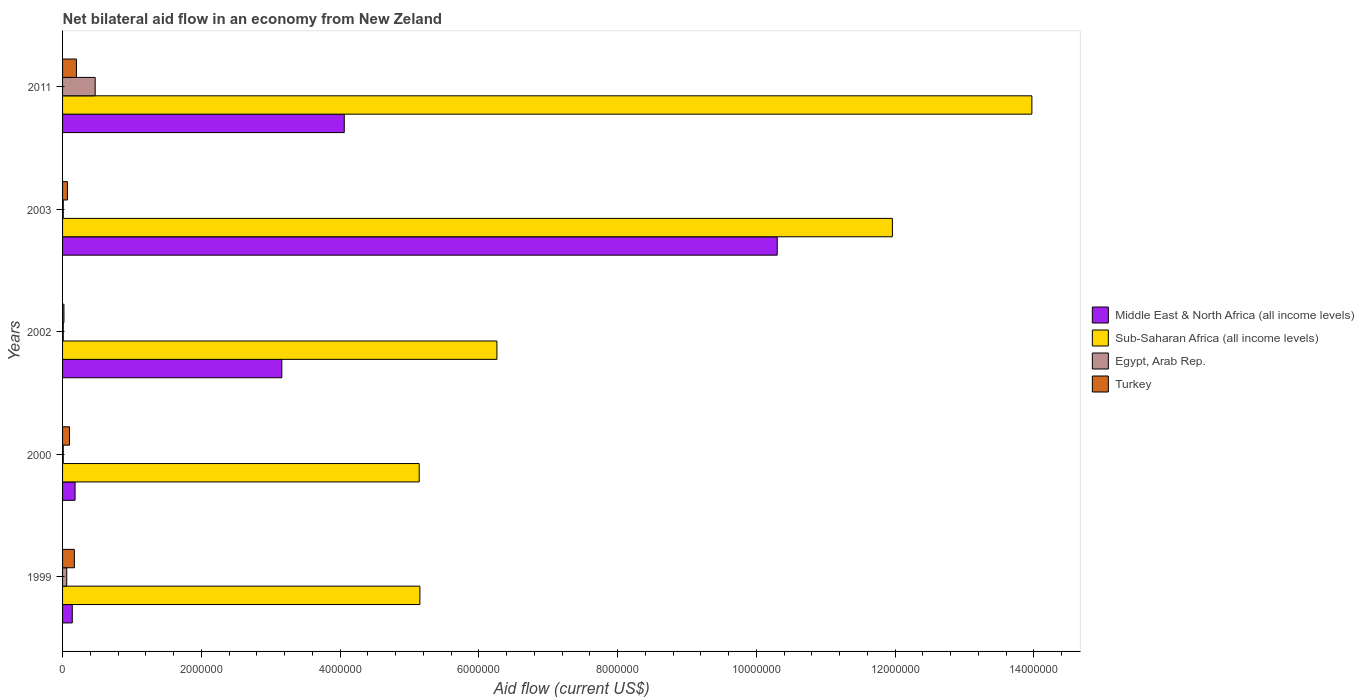How many different coloured bars are there?
Provide a succinct answer. 4. Are the number of bars per tick equal to the number of legend labels?
Your response must be concise. Yes. Are the number of bars on each tick of the Y-axis equal?
Your answer should be compact. Yes. How many bars are there on the 1st tick from the bottom?
Your answer should be very brief. 4. In how many cases, is the number of bars for a given year not equal to the number of legend labels?
Provide a short and direct response. 0. What is the net bilateral aid flow in Turkey in 1999?
Your answer should be very brief. 1.70e+05. Across all years, what is the minimum net bilateral aid flow in Middle East & North Africa (all income levels)?
Offer a very short reply. 1.40e+05. In which year was the net bilateral aid flow in Middle East & North Africa (all income levels) maximum?
Ensure brevity in your answer.  2003. In which year was the net bilateral aid flow in Sub-Saharan Africa (all income levels) minimum?
Provide a short and direct response. 2000. What is the total net bilateral aid flow in Sub-Saharan Africa (all income levels) in the graph?
Make the answer very short. 4.25e+07. What is the difference between the net bilateral aid flow in Sub-Saharan Africa (all income levels) in 1999 and that in 2003?
Make the answer very short. -6.81e+06. What is the average net bilateral aid flow in Sub-Saharan Africa (all income levels) per year?
Offer a very short reply. 8.50e+06. In the year 2003, what is the difference between the net bilateral aid flow in Middle East & North Africa (all income levels) and net bilateral aid flow in Turkey?
Give a very brief answer. 1.02e+07. In how many years, is the net bilateral aid flow in Sub-Saharan Africa (all income levels) greater than 7200000 US$?
Offer a very short reply. 2. Is the difference between the net bilateral aid flow in Middle East & North Africa (all income levels) in 2000 and 2003 greater than the difference between the net bilateral aid flow in Turkey in 2000 and 2003?
Keep it short and to the point. No. What is the difference between the highest and the second highest net bilateral aid flow in Sub-Saharan Africa (all income levels)?
Your answer should be compact. 2.01e+06. What is the difference between the highest and the lowest net bilateral aid flow in Turkey?
Make the answer very short. 1.80e+05. In how many years, is the net bilateral aid flow in Sub-Saharan Africa (all income levels) greater than the average net bilateral aid flow in Sub-Saharan Africa (all income levels) taken over all years?
Keep it short and to the point. 2. Is the sum of the net bilateral aid flow in Middle East & North Africa (all income levels) in 2000 and 2003 greater than the maximum net bilateral aid flow in Egypt, Arab Rep. across all years?
Give a very brief answer. Yes. What does the 4th bar from the top in 2003 represents?
Offer a terse response. Middle East & North Africa (all income levels). Is it the case that in every year, the sum of the net bilateral aid flow in Egypt, Arab Rep. and net bilateral aid flow in Turkey is greater than the net bilateral aid flow in Middle East & North Africa (all income levels)?
Your response must be concise. No. Does the graph contain any zero values?
Give a very brief answer. No. Does the graph contain grids?
Your response must be concise. No. How are the legend labels stacked?
Offer a very short reply. Vertical. What is the title of the graph?
Provide a succinct answer. Net bilateral aid flow in an economy from New Zeland. Does "Benin" appear as one of the legend labels in the graph?
Your response must be concise. No. What is the Aid flow (current US$) of Middle East & North Africa (all income levels) in 1999?
Provide a succinct answer. 1.40e+05. What is the Aid flow (current US$) in Sub-Saharan Africa (all income levels) in 1999?
Ensure brevity in your answer.  5.15e+06. What is the Aid flow (current US$) of Egypt, Arab Rep. in 1999?
Keep it short and to the point. 6.00e+04. What is the Aid flow (current US$) in Sub-Saharan Africa (all income levels) in 2000?
Keep it short and to the point. 5.14e+06. What is the Aid flow (current US$) of Turkey in 2000?
Your response must be concise. 1.00e+05. What is the Aid flow (current US$) of Middle East & North Africa (all income levels) in 2002?
Offer a very short reply. 3.16e+06. What is the Aid flow (current US$) of Sub-Saharan Africa (all income levels) in 2002?
Offer a terse response. 6.26e+06. What is the Aid flow (current US$) in Egypt, Arab Rep. in 2002?
Your answer should be very brief. 10000. What is the Aid flow (current US$) of Middle East & North Africa (all income levels) in 2003?
Your answer should be very brief. 1.03e+07. What is the Aid flow (current US$) of Sub-Saharan Africa (all income levels) in 2003?
Offer a terse response. 1.20e+07. What is the Aid flow (current US$) of Middle East & North Africa (all income levels) in 2011?
Provide a succinct answer. 4.06e+06. What is the Aid flow (current US$) in Sub-Saharan Africa (all income levels) in 2011?
Provide a succinct answer. 1.40e+07. What is the Aid flow (current US$) in Egypt, Arab Rep. in 2011?
Make the answer very short. 4.70e+05. What is the Aid flow (current US$) in Turkey in 2011?
Your response must be concise. 2.00e+05. Across all years, what is the maximum Aid flow (current US$) of Middle East & North Africa (all income levels)?
Ensure brevity in your answer.  1.03e+07. Across all years, what is the maximum Aid flow (current US$) of Sub-Saharan Africa (all income levels)?
Your answer should be very brief. 1.40e+07. Across all years, what is the minimum Aid flow (current US$) of Sub-Saharan Africa (all income levels)?
Offer a very short reply. 5.14e+06. Across all years, what is the minimum Aid flow (current US$) in Egypt, Arab Rep.?
Ensure brevity in your answer.  10000. Across all years, what is the minimum Aid flow (current US$) in Turkey?
Provide a succinct answer. 2.00e+04. What is the total Aid flow (current US$) of Middle East & North Africa (all income levels) in the graph?
Offer a terse response. 1.78e+07. What is the total Aid flow (current US$) in Sub-Saharan Africa (all income levels) in the graph?
Give a very brief answer. 4.25e+07. What is the total Aid flow (current US$) in Egypt, Arab Rep. in the graph?
Provide a short and direct response. 5.60e+05. What is the total Aid flow (current US$) in Turkey in the graph?
Offer a terse response. 5.60e+05. What is the difference between the Aid flow (current US$) in Sub-Saharan Africa (all income levels) in 1999 and that in 2000?
Give a very brief answer. 10000. What is the difference between the Aid flow (current US$) of Egypt, Arab Rep. in 1999 and that in 2000?
Give a very brief answer. 5.00e+04. What is the difference between the Aid flow (current US$) of Turkey in 1999 and that in 2000?
Ensure brevity in your answer.  7.00e+04. What is the difference between the Aid flow (current US$) in Middle East & North Africa (all income levels) in 1999 and that in 2002?
Provide a short and direct response. -3.02e+06. What is the difference between the Aid flow (current US$) in Sub-Saharan Africa (all income levels) in 1999 and that in 2002?
Your answer should be very brief. -1.11e+06. What is the difference between the Aid flow (current US$) of Egypt, Arab Rep. in 1999 and that in 2002?
Give a very brief answer. 5.00e+04. What is the difference between the Aid flow (current US$) in Middle East & North Africa (all income levels) in 1999 and that in 2003?
Your answer should be very brief. -1.02e+07. What is the difference between the Aid flow (current US$) of Sub-Saharan Africa (all income levels) in 1999 and that in 2003?
Provide a short and direct response. -6.81e+06. What is the difference between the Aid flow (current US$) of Egypt, Arab Rep. in 1999 and that in 2003?
Provide a short and direct response. 5.00e+04. What is the difference between the Aid flow (current US$) of Middle East & North Africa (all income levels) in 1999 and that in 2011?
Provide a succinct answer. -3.92e+06. What is the difference between the Aid flow (current US$) in Sub-Saharan Africa (all income levels) in 1999 and that in 2011?
Your answer should be very brief. -8.82e+06. What is the difference between the Aid flow (current US$) of Egypt, Arab Rep. in 1999 and that in 2011?
Provide a short and direct response. -4.10e+05. What is the difference between the Aid flow (current US$) in Turkey in 1999 and that in 2011?
Keep it short and to the point. -3.00e+04. What is the difference between the Aid flow (current US$) of Middle East & North Africa (all income levels) in 2000 and that in 2002?
Make the answer very short. -2.98e+06. What is the difference between the Aid flow (current US$) in Sub-Saharan Africa (all income levels) in 2000 and that in 2002?
Your answer should be very brief. -1.12e+06. What is the difference between the Aid flow (current US$) of Turkey in 2000 and that in 2002?
Offer a terse response. 8.00e+04. What is the difference between the Aid flow (current US$) of Middle East & North Africa (all income levels) in 2000 and that in 2003?
Your response must be concise. -1.01e+07. What is the difference between the Aid flow (current US$) in Sub-Saharan Africa (all income levels) in 2000 and that in 2003?
Your answer should be compact. -6.82e+06. What is the difference between the Aid flow (current US$) in Egypt, Arab Rep. in 2000 and that in 2003?
Give a very brief answer. 0. What is the difference between the Aid flow (current US$) of Turkey in 2000 and that in 2003?
Your response must be concise. 3.00e+04. What is the difference between the Aid flow (current US$) in Middle East & North Africa (all income levels) in 2000 and that in 2011?
Give a very brief answer. -3.88e+06. What is the difference between the Aid flow (current US$) of Sub-Saharan Africa (all income levels) in 2000 and that in 2011?
Provide a succinct answer. -8.83e+06. What is the difference between the Aid flow (current US$) of Egypt, Arab Rep. in 2000 and that in 2011?
Provide a short and direct response. -4.60e+05. What is the difference between the Aid flow (current US$) in Middle East & North Africa (all income levels) in 2002 and that in 2003?
Your answer should be compact. -7.14e+06. What is the difference between the Aid flow (current US$) in Sub-Saharan Africa (all income levels) in 2002 and that in 2003?
Offer a very short reply. -5.70e+06. What is the difference between the Aid flow (current US$) in Egypt, Arab Rep. in 2002 and that in 2003?
Your answer should be very brief. 0. What is the difference between the Aid flow (current US$) in Middle East & North Africa (all income levels) in 2002 and that in 2011?
Give a very brief answer. -9.00e+05. What is the difference between the Aid flow (current US$) in Sub-Saharan Africa (all income levels) in 2002 and that in 2011?
Ensure brevity in your answer.  -7.71e+06. What is the difference between the Aid flow (current US$) in Egypt, Arab Rep. in 2002 and that in 2011?
Ensure brevity in your answer.  -4.60e+05. What is the difference between the Aid flow (current US$) of Turkey in 2002 and that in 2011?
Offer a terse response. -1.80e+05. What is the difference between the Aid flow (current US$) in Middle East & North Africa (all income levels) in 2003 and that in 2011?
Make the answer very short. 6.24e+06. What is the difference between the Aid flow (current US$) of Sub-Saharan Africa (all income levels) in 2003 and that in 2011?
Offer a terse response. -2.01e+06. What is the difference between the Aid flow (current US$) of Egypt, Arab Rep. in 2003 and that in 2011?
Your answer should be compact. -4.60e+05. What is the difference between the Aid flow (current US$) in Turkey in 2003 and that in 2011?
Your response must be concise. -1.30e+05. What is the difference between the Aid flow (current US$) in Middle East & North Africa (all income levels) in 1999 and the Aid flow (current US$) in Sub-Saharan Africa (all income levels) in 2000?
Provide a succinct answer. -5.00e+06. What is the difference between the Aid flow (current US$) of Middle East & North Africa (all income levels) in 1999 and the Aid flow (current US$) of Turkey in 2000?
Your answer should be very brief. 4.00e+04. What is the difference between the Aid flow (current US$) of Sub-Saharan Africa (all income levels) in 1999 and the Aid flow (current US$) of Egypt, Arab Rep. in 2000?
Provide a short and direct response. 5.14e+06. What is the difference between the Aid flow (current US$) of Sub-Saharan Africa (all income levels) in 1999 and the Aid flow (current US$) of Turkey in 2000?
Provide a succinct answer. 5.05e+06. What is the difference between the Aid flow (current US$) in Egypt, Arab Rep. in 1999 and the Aid flow (current US$) in Turkey in 2000?
Provide a succinct answer. -4.00e+04. What is the difference between the Aid flow (current US$) in Middle East & North Africa (all income levels) in 1999 and the Aid flow (current US$) in Sub-Saharan Africa (all income levels) in 2002?
Provide a short and direct response. -6.12e+06. What is the difference between the Aid flow (current US$) in Middle East & North Africa (all income levels) in 1999 and the Aid flow (current US$) in Egypt, Arab Rep. in 2002?
Ensure brevity in your answer.  1.30e+05. What is the difference between the Aid flow (current US$) in Sub-Saharan Africa (all income levels) in 1999 and the Aid flow (current US$) in Egypt, Arab Rep. in 2002?
Give a very brief answer. 5.14e+06. What is the difference between the Aid flow (current US$) of Sub-Saharan Africa (all income levels) in 1999 and the Aid flow (current US$) of Turkey in 2002?
Give a very brief answer. 5.13e+06. What is the difference between the Aid flow (current US$) of Egypt, Arab Rep. in 1999 and the Aid flow (current US$) of Turkey in 2002?
Offer a terse response. 4.00e+04. What is the difference between the Aid flow (current US$) of Middle East & North Africa (all income levels) in 1999 and the Aid flow (current US$) of Sub-Saharan Africa (all income levels) in 2003?
Provide a short and direct response. -1.18e+07. What is the difference between the Aid flow (current US$) in Middle East & North Africa (all income levels) in 1999 and the Aid flow (current US$) in Egypt, Arab Rep. in 2003?
Provide a short and direct response. 1.30e+05. What is the difference between the Aid flow (current US$) of Sub-Saharan Africa (all income levels) in 1999 and the Aid flow (current US$) of Egypt, Arab Rep. in 2003?
Ensure brevity in your answer.  5.14e+06. What is the difference between the Aid flow (current US$) in Sub-Saharan Africa (all income levels) in 1999 and the Aid flow (current US$) in Turkey in 2003?
Offer a very short reply. 5.08e+06. What is the difference between the Aid flow (current US$) of Middle East & North Africa (all income levels) in 1999 and the Aid flow (current US$) of Sub-Saharan Africa (all income levels) in 2011?
Ensure brevity in your answer.  -1.38e+07. What is the difference between the Aid flow (current US$) of Middle East & North Africa (all income levels) in 1999 and the Aid flow (current US$) of Egypt, Arab Rep. in 2011?
Offer a terse response. -3.30e+05. What is the difference between the Aid flow (current US$) of Middle East & North Africa (all income levels) in 1999 and the Aid flow (current US$) of Turkey in 2011?
Offer a very short reply. -6.00e+04. What is the difference between the Aid flow (current US$) of Sub-Saharan Africa (all income levels) in 1999 and the Aid flow (current US$) of Egypt, Arab Rep. in 2011?
Provide a short and direct response. 4.68e+06. What is the difference between the Aid flow (current US$) in Sub-Saharan Africa (all income levels) in 1999 and the Aid flow (current US$) in Turkey in 2011?
Provide a short and direct response. 4.95e+06. What is the difference between the Aid flow (current US$) in Egypt, Arab Rep. in 1999 and the Aid flow (current US$) in Turkey in 2011?
Your answer should be compact. -1.40e+05. What is the difference between the Aid flow (current US$) in Middle East & North Africa (all income levels) in 2000 and the Aid flow (current US$) in Sub-Saharan Africa (all income levels) in 2002?
Provide a succinct answer. -6.08e+06. What is the difference between the Aid flow (current US$) in Middle East & North Africa (all income levels) in 2000 and the Aid flow (current US$) in Egypt, Arab Rep. in 2002?
Ensure brevity in your answer.  1.70e+05. What is the difference between the Aid flow (current US$) of Middle East & North Africa (all income levels) in 2000 and the Aid flow (current US$) of Turkey in 2002?
Your response must be concise. 1.60e+05. What is the difference between the Aid flow (current US$) of Sub-Saharan Africa (all income levels) in 2000 and the Aid flow (current US$) of Egypt, Arab Rep. in 2002?
Provide a succinct answer. 5.13e+06. What is the difference between the Aid flow (current US$) in Sub-Saharan Africa (all income levels) in 2000 and the Aid flow (current US$) in Turkey in 2002?
Offer a terse response. 5.12e+06. What is the difference between the Aid flow (current US$) of Middle East & North Africa (all income levels) in 2000 and the Aid flow (current US$) of Sub-Saharan Africa (all income levels) in 2003?
Your answer should be very brief. -1.18e+07. What is the difference between the Aid flow (current US$) of Sub-Saharan Africa (all income levels) in 2000 and the Aid flow (current US$) of Egypt, Arab Rep. in 2003?
Offer a very short reply. 5.13e+06. What is the difference between the Aid flow (current US$) in Sub-Saharan Africa (all income levels) in 2000 and the Aid flow (current US$) in Turkey in 2003?
Make the answer very short. 5.07e+06. What is the difference between the Aid flow (current US$) in Egypt, Arab Rep. in 2000 and the Aid flow (current US$) in Turkey in 2003?
Your response must be concise. -6.00e+04. What is the difference between the Aid flow (current US$) of Middle East & North Africa (all income levels) in 2000 and the Aid flow (current US$) of Sub-Saharan Africa (all income levels) in 2011?
Provide a succinct answer. -1.38e+07. What is the difference between the Aid flow (current US$) of Middle East & North Africa (all income levels) in 2000 and the Aid flow (current US$) of Turkey in 2011?
Give a very brief answer. -2.00e+04. What is the difference between the Aid flow (current US$) of Sub-Saharan Africa (all income levels) in 2000 and the Aid flow (current US$) of Egypt, Arab Rep. in 2011?
Your response must be concise. 4.67e+06. What is the difference between the Aid flow (current US$) in Sub-Saharan Africa (all income levels) in 2000 and the Aid flow (current US$) in Turkey in 2011?
Your answer should be compact. 4.94e+06. What is the difference between the Aid flow (current US$) of Middle East & North Africa (all income levels) in 2002 and the Aid flow (current US$) of Sub-Saharan Africa (all income levels) in 2003?
Your response must be concise. -8.80e+06. What is the difference between the Aid flow (current US$) in Middle East & North Africa (all income levels) in 2002 and the Aid flow (current US$) in Egypt, Arab Rep. in 2003?
Your response must be concise. 3.15e+06. What is the difference between the Aid flow (current US$) of Middle East & North Africa (all income levels) in 2002 and the Aid flow (current US$) of Turkey in 2003?
Offer a terse response. 3.09e+06. What is the difference between the Aid flow (current US$) in Sub-Saharan Africa (all income levels) in 2002 and the Aid flow (current US$) in Egypt, Arab Rep. in 2003?
Ensure brevity in your answer.  6.25e+06. What is the difference between the Aid flow (current US$) in Sub-Saharan Africa (all income levels) in 2002 and the Aid flow (current US$) in Turkey in 2003?
Your response must be concise. 6.19e+06. What is the difference between the Aid flow (current US$) in Middle East & North Africa (all income levels) in 2002 and the Aid flow (current US$) in Sub-Saharan Africa (all income levels) in 2011?
Provide a short and direct response. -1.08e+07. What is the difference between the Aid flow (current US$) in Middle East & North Africa (all income levels) in 2002 and the Aid flow (current US$) in Egypt, Arab Rep. in 2011?
Provide a succinct answer. 2.69e+06. What is the difference between the Aid flow (current US$) of Middle East & North Africa (all income levels) in 2002 and the Aid flow (current US$) of Turkey in 2011?
Give a very brief answer. 2.96e+06. What is the difference between the Aid flow (current US$) of Sub-Saharan Africa (all income levels) in 2002 and the Aid flow (current US$) of Egypt, Arab Rep. in 2011?
Provide a succinct answer. 5.79e+06. What is the difference between the Aid flow (current US$) in Sub-Saharan Africa (all income levels) in 2002 and the Aid flow (current US$) in Turkey in 2011?
Ensure brevity in your answer.  6.06e+06. What is the difference between the Aid flow (current US$) in Middle East & North Africa (all income levels) in 2003 and the Aid flow (current US$) in Sub-Saharan Africa (all income levels) in 2011?
Your answer should be compact. -3.67e+06. What is the difference between the Aid flow (current US$) in Middle East & North Africa (all income levels) in 2003 and the Aid flow (current US$) in Egypt, Arab Rep. in 2011?
Give a very brief answer. 9.83e+06. What is the difference between the Aid flow (current US$) in Middle East & North Africa (all income levels) in 2003 and the Aid flow (current US$) in Turkey in 2011?
Ensure brevity in your answer.  1.01e+07. What is the difference between the Aid flow (current US$) of Sub-Saharan Africa (all income levels) in 2003 and the Aid flow (current US$) of Egypt, Arab Rep. in 2011?
Give a very brief answer. 1.15e+07. What is the difference between the Aid flow (current US$) in Sub-Saharan Africa (all income levels) in 2003 and the Aid flow (current US$) in Turkey in 2011?
Your response must be concise. 1.18e+07. What is the difference between the Aid flow (current US$) of Egypt, Arab Rep. in 2003 and the Aid flow (current US$) of Turkey in 2011?
Give a very brief answer. -1.90e+05. What is the average Aid flow (current US$) of Middle East & North Africa (all income levels) per year?
Your answer should be very brief. 3.57e+06. What is the average Aid flow (current US$) in Sub-Saharan Africa (all income levels) per year?
Offer a very short reply. 8.50e+06. What is the average Aid flow (current US$) of Egypt, Arab Rep. per year?
Your response must be concise. 1.12e+05. What is the average Aid flow (current US$) of Turkey per year?
Offer a terse response. 1.12e+05. In the year 1999, what is the difference between the Aid flow (current US$) in Middle East & North Africa (all income levels) and Aid flow (current US$) in Sub-Saharan Africa (all income levels)?
Make the answer very short. -5.01e+06. In the year 1999, what is the difference between the Aid flow (current US$) of Middle East & North Africa (all income levels) and Aid flow (current US$) of Egypt, Arab Rep.?
Ensure brevity in your answer.  8.00e+04. In the year 1999, what is the difference between the Aid flow (current US$) of Sub-Saharan Africa (all income levels) and Aid flow (current US$) of Egypt, Arab Rep.?
Provide a short and direct response. 5.09e+06. In the year 1999, what is the difference between the Aid flow (current US$) of Sub-Saharan Africa (all income levels) and Aid flow (current US$) of Turkey?
Offer a terse response. 4.98e+06. In the year 1999, what is the difference between the Aid flow (current US$) of Egypt, Arab Rep. and Aid flow (current US$) of Turkey?
Offer a very short reply. -1.10e+05. In the year 2000, what is the difference between the Aid flow (current US$) of Middle East & North Africa (all income levels) and Aid flow (current US$) of Sub-Saharan Africa (all income levels)?
Provide a short and direct response. -4.96e+06. In the year 2000, what is the difference between the Aid flow (current US$) of Middle East & North Africa (all income levels) and Aid flow (current US$) of Turkey?
Your answer should be very brief. 8.00e+04. In the year 2000, what is the difference between the Aid flow (current US$) in Sub-Saharan Africa (all income levels) and Aid flow (current US$) in Egypt, Arab Rep.?
Offer a terse response. 5.13e+06. In the year 2000, what is the difference between the Aid flow (current US$) in Sub-Saharan Africa (all income levels) and Aid flow (current US$) in Turkey?
Offer a very short reply. 5.04e+06. In the year 2000, what is the difference between the Aid flow (current US$) of Egypt, Arab Rep. and Aid flow (current US$) of Turkey?
Your response must be concise. -9.00e+04. In the year 2002, what is the difference between the Aid flow (current US$) in Middle East & North Africa (all income levels) and Aid flow (current US$) in Sub-Saharan Africa (all income levels)?
Ensure brevity in your answer.  -3.10e+06. In the year 2002, what is the difference between the Aid flow (current US$) in Middle East & North Africa (all income levels) and Aid flow (current US$) in Egypt, Arab Rep.?
Make the answer very short. 3.15e+06. In the year 2002, what is the difference between the Aid flow (current US$) of Middle East & North Africa (all income levels) and Aid flow (current US$) of Turkey?
Provide a succinct answer. 3.14e+06. In the year 2002, what is the difference between the Aid flow (current US$) in Sub-Saharan Africa (all income levels) and Aid flow (current US$) in Egypt, Arab Rep.?
Make the answer very short. 6.25e+06. In the year 2002, what is the difference between the Aid flow (current US$) in Sub-Saharan Africa (all income levels) and Aid flow (current US$) in Turkey?
Provide a short and direct response. 6.24e+06. In the year 2002, what is the difference between the Aid flow (current US$) in Egypt, Arab Rep. and Aid flow (current US$) in Turkey?
Give a very brief answer. -10000. In the year 2003, what is the difference between the Aid flow (current US$) of Middle East & North Africa (all income levels) and Aid flow (current US$) of Sub-Saharan Africa (all income levels)?
Offer a very short reply. -1.66e+06. In the year 2003, what is the difference between the Aid flow (current US$) in Middle East & North Africa (all income levels) and Aid flow (current US$) in Egypt, Arab Rep.?
Provide a short and direct response. 1.03e+07. In the year 2003, what is the difference between the Aid flow (current US$) in Middle East & North Africa (all income levels) and Aid flow (current US$) in Turkey?
Keep it short and to the point. 1.02e+07. In the year 2003, what is the difference between the Aid flow (current US$) in Sub-Saharan Africa (all income levels) and Aid flow (current US$) in Egypt, Arab Rep.?
Your response must be concise. 1.20e+07. In the year 2003, what is the difference between the Aid flow (current US$) in Sub-Saharan Africa (all income levels) and Aid flow (current US$) in Turkey?
Ensure brevity in your answer.  1.19e+07. In the year 2011, what is the difference between the Aid flow (current US$) of Middle East & North Africa (all income levels) and Aid flow (current US$) of Sub-Saharan Africa (all income levels)?
Your response must be concise. -9.91e+06. In the year 2011, what is the difference between the Aid flow (current US$) of Middle East & North Africa (all income levels) and Aid flow (current US$) of Egypt, Arab Rep.?
Ensure brevity in your answer.  3.59e+06. In the year 2011, what is the difference between the Aid flow (current US$) of Middle East & North Africa (all income levels) and Aid flow (current US$) of Turkey?
Offer a very short reply. 3.86e+06. In the year 2011, what is the difference between the Aid flow (current US$) of Sub-Saharan Africa (all income levels) and Aid flow (current US$) of Egypt, Arab Rep.?
Provide a succinct answer. 1.35e+07. In the year 2011, what is the difference between the Aid flow (current US$) in Sub-Saharan Africa (all income levels) and Aid flow (current US$) in Turkey?
Your answer should be compact. 1.38e+07. What is the ratio of the Aid flow (current US$) in Middle East & North Africa (all income levels) in 1999 to that in 2000?
Keep it short and to the point. 0.78. What is the ratio of the Aid flow (current US$) of Egypt, Arab Rep. in 1999 to that in 2000?
Provide a short and direct response. 6. What is the ratio of the Aid flow (current US$) in Turkey in 1999 to that in 2000?
Your answer should be compact. 1.7. What is the ratio of the Aid flow (current US$) of Middle East & North Africa (all income levels) in 1999 to that in 2002?
Give a very brief answer. 0.04. What is the ratio of the Aid flow (current US$) in Sub-Saharan Africa (all income levels) in 1999 to that in 2002?
Give a very brief answer. 0.82. What is the ratio of the Aid flow (current US$) of Egypt, Arab Rep. in 1999 to that in 2002?
Offer a very short reply. 6. What is the ratio of the Aid flow (current US$) of Middle East & North Africa (all income levels) in 1999 to that in 2003?
Offer a terse response. 0.01. What is the ratio of the Aid flow (current US$) of Sub-Saharan Africa (all income levels) in 1999 to that in 2003?
Your answer should be very brief. 0.43. What is the ratio of the Aid flow (current US$) in Turkey in 1999 to that in 2003?
Keep it short and to the point. 2.43. What is the ratio of the Aid flow (current US$) of Middle East & North Africa (all income levels) in 1999 to that in 2011?
Provide a short and direct response. 0.03. What is the ratio of the Aid flow (current US$) of Sub-Saharan Africa (all income levels) in 1999 to that in 2011?
Provide a succinct answer. 0.37. What is the ratio of the Aid flow (current US$) in Egypt, Arab Rep. in 1999 to that in 2011?
Provide a succinct answer. 0.13. What is the ratio of the Aid flow (current US$) in Turkey in 1999 to that in 2011?
Keep it short and to the point. 0.85. What is the ratio of the Aid flow (current US$) in Middle East & North Africa (all income levels) in 2000 to that in 2002?
Your answer should be very brief. 0.06. What is the ratio of the Aid flow (current US$) in Sub-Saharan Africa (all income levels) in 2000 to that in 2002?
Ensure brevity in your answer.  0.82. What is the ratio of the Aid flow (current US$) of Middle East & North Africa (all income levels) in 2000 to that in 2003?
Your answer should be very brief. 0.02. What is the ratio of the Aid flow (current US$) in Sub-Saharan Africa (all income levels) in 2000 to that in 2003?
Your answer should be compact. 0.43. What is the ratio of the Aid flow (current US$) in Egypt, Arab Rep. in 2000 to that in 2003?
Provide a succinct answer. 1. What is the ratio of the Aid flow (current US$) of Turkey in 2000 to that in 2003?
Your answer should be very brief. 1.43. What is the ratio of the Aid flow (current US$) in Middle East & North Africa (all income levels) in 2000 to that in 2011?
Provide a succinct answer. 0.04. What is the ratio of the Aid flow (current US$) of Sub-Saharan Africa (all income levels) in 2000 to that in 2011?
Provide a short and direct response. 0.37. What is the ratio of the Aid flow (current US$) in Egypt, Arab Rep. in 2000 to that in 2011?
Your answer should be compact. 0.02. What is the ratio of the Aid flow (current US$) in Turkey in 2000 to that in 2011?
Your answer should be very brief. 0.5. What is the ratio of the Aid flow (current US$) of Middle East & North Africa (all income levels) in 2002 to that in 2003?
Offer a terse response. 0.31. What is the ratio of the Aid flow (current US$) in Sub-Saharan Africa (all income levels) in 2002 to that in 2003?
Ensure brevity in your answer.  0.52. What is the ratio of the Aid flow (current US$) in Turkey in 2002 to that in 2003?
Provide a succinct answer. 0.29. What is the ratio of the Aid flow (current US$) in Middle East & North Africa (all income levels) in 2002 to that in 2011?
Ensure brevity in your answer.  0.78. What is the ratio of the Aid flow (current US$) in Sub-Saharan Africa (all income levels) in 2002 to that in 2011?
Offer a terse response. 0.45. What is the ratio of the Aid flow (current US$) in Egypt, Arab Rep. in 2002 to that in 2011?
Your answer should be very brief. 0.02. What is the ratio of the Aid flow (current US$) in Middle East & North Africa (all income levels) in 2003 to that in 2011?
Offer a very short reply. 2.54. What is the ratio of the Aid flow (current US$) of Sub-Saharan Africa (all income levels) in 2003 to that in 2011?
Your response must be concise. 0.86. What is the ratio of the Aid flow (current US$) in Egypt, Arab Rep. in 2003 to that in 2011?
Keep it short and to the point. 0.02. What is the difference between the highest and the second highest Aid flow (current US$) of Middle East & North Africa (all income levels)?
Provide a succinct answer. 6.24e+06. What is the difference between the highest and the second highest Aid flow (current US$) of Sub-Saharan Africa (all income levels)?
Offer a very short reply. 2.01e+06. What is the difference between the highest and the second highest Aid flow (current US$) in Egypt, Arab Rep.?
Your response must be concise. 4.10e+05. What is the difference between the highest and the second highest Aid flow (current US$) in Turkey?
Offer a terse response. 3.00e+04. What is the difference between the highest and the lowest Aid flow (current US$) of Middle East & North Africa (all income levels)?
Offer a very short reply. 1.02e+07. What is the difference between the highest and the lowest Aid flow (current US$) of Sub-Saharan Africa (all income levels)?
Offer a very short reply. 8.83e+06. What is the difference between the highest and the lowest Aid flow (current US$) in Egypt, Arab Rep.?
Offer a very short reply. 4.60e+05. What is the difference between the highest and the lowest Aid flow (current US$) of Turkey?
Give a very brief answer. 1.80e+05. 